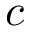<formula> <loc_0><loc_0><loc_500><loc_500>c</formula> 